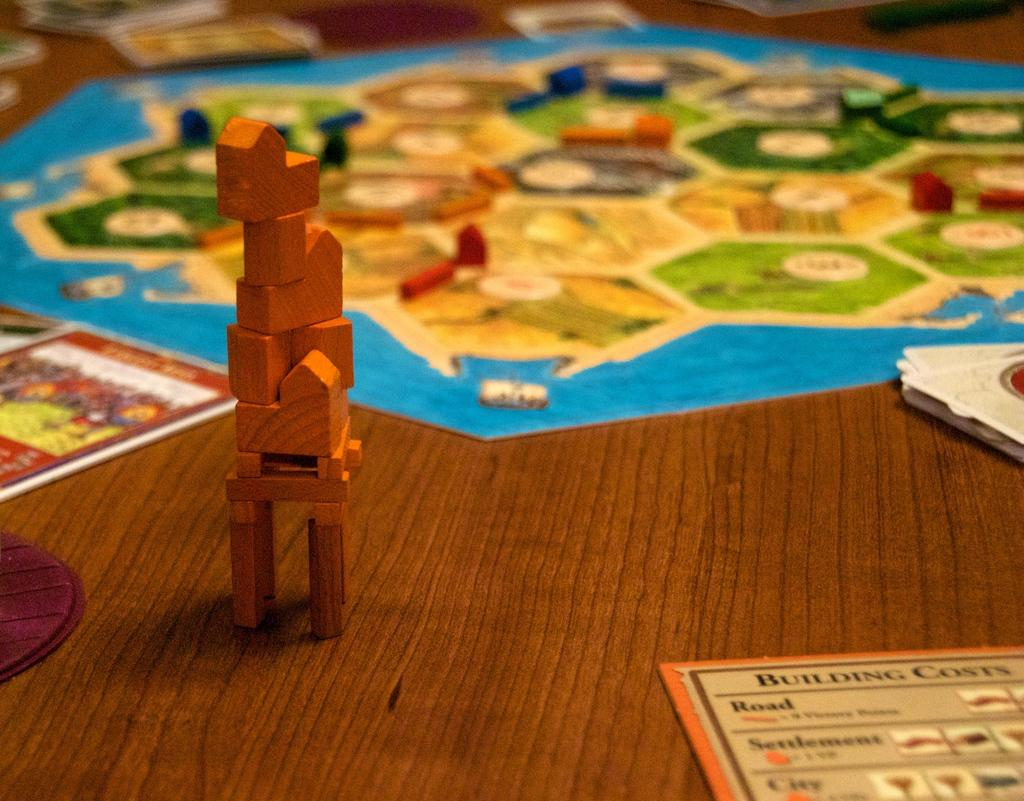<image>
Render a clear and concise summary of the photo. a paper on a table that says 'building costs' on it 